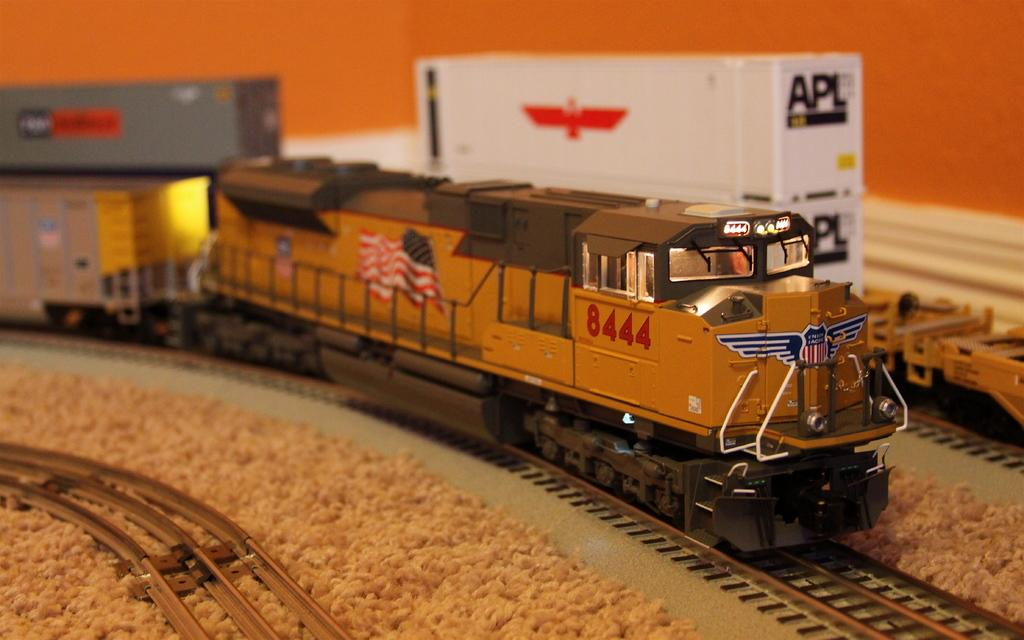What type of vehicles are in the image? There are trains in the image. Where are the trains located? The trains are on a railway track. What colors can be seen on the trains? The trains are in brown, white, and ash colors. What can be seen in the background of the image? There is an orange wall visible in the background of the image. Can you tell me how many dimes are scattered around the trains in the image? There are no dimes present in the image; it only features trains on a railway track. 